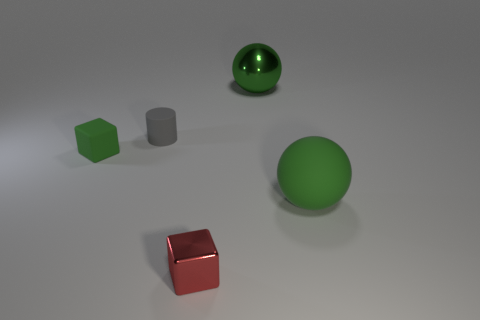Add 2 gray metal cubes. How many objects exist? 7 Subtract all spheres. How many objects are left? 3 Subtract all small green matte cubes. Subtract all green rubber balls. How many objects are left? 3 Add 4 gray cylinders. How many gray cylinders are left? 5 Add 3 purple metal blocks. How many purple metal blocks exist? 3 Subtract 1 gray cylinders. How many objects are left? 4 